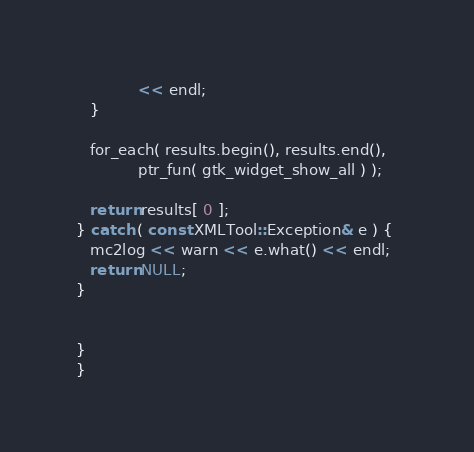Convert code to text. <code><loc_0><loc_0><loc_500><loc_500><_C++_>             << endl;
   }

   for_each( results.begin(), results.end(), 
             ptr_fun( gtk_widget_show_all ) );

   return results[ 0 ];
} catch ( const XMLTool::Exception& e ) { 
   mc2log << warn << e.what() << endl;
   return NULL;
}


}
}
</code> 